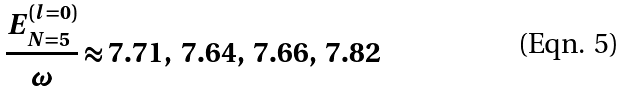<formula> <loc_0><loc_0><loc_500><loc_500>\frac { E _ { N = 5 } ^ { ( l = 0 ) } } { \omega } \approx 7 . 7 1 , \ 7 . 6 4 , \ 7 . 6 6 , \ 7 . 8 2</formula> 